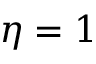Convert formula to latex. <formula><loc_0><loc_0><loc_500><loc_500>\eta = 1</formula> 